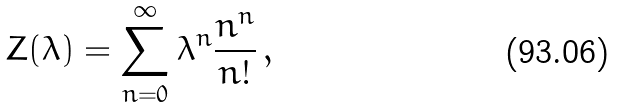<formula> <loc_0><loc_0><loc_500><loc_500>\, Z ( \lambda ) = \sum _ { n = 0 } ^ { \infty } \lambda ^ { n } \frac { n ^ { n } } { n ! } \, , \,</formula> 